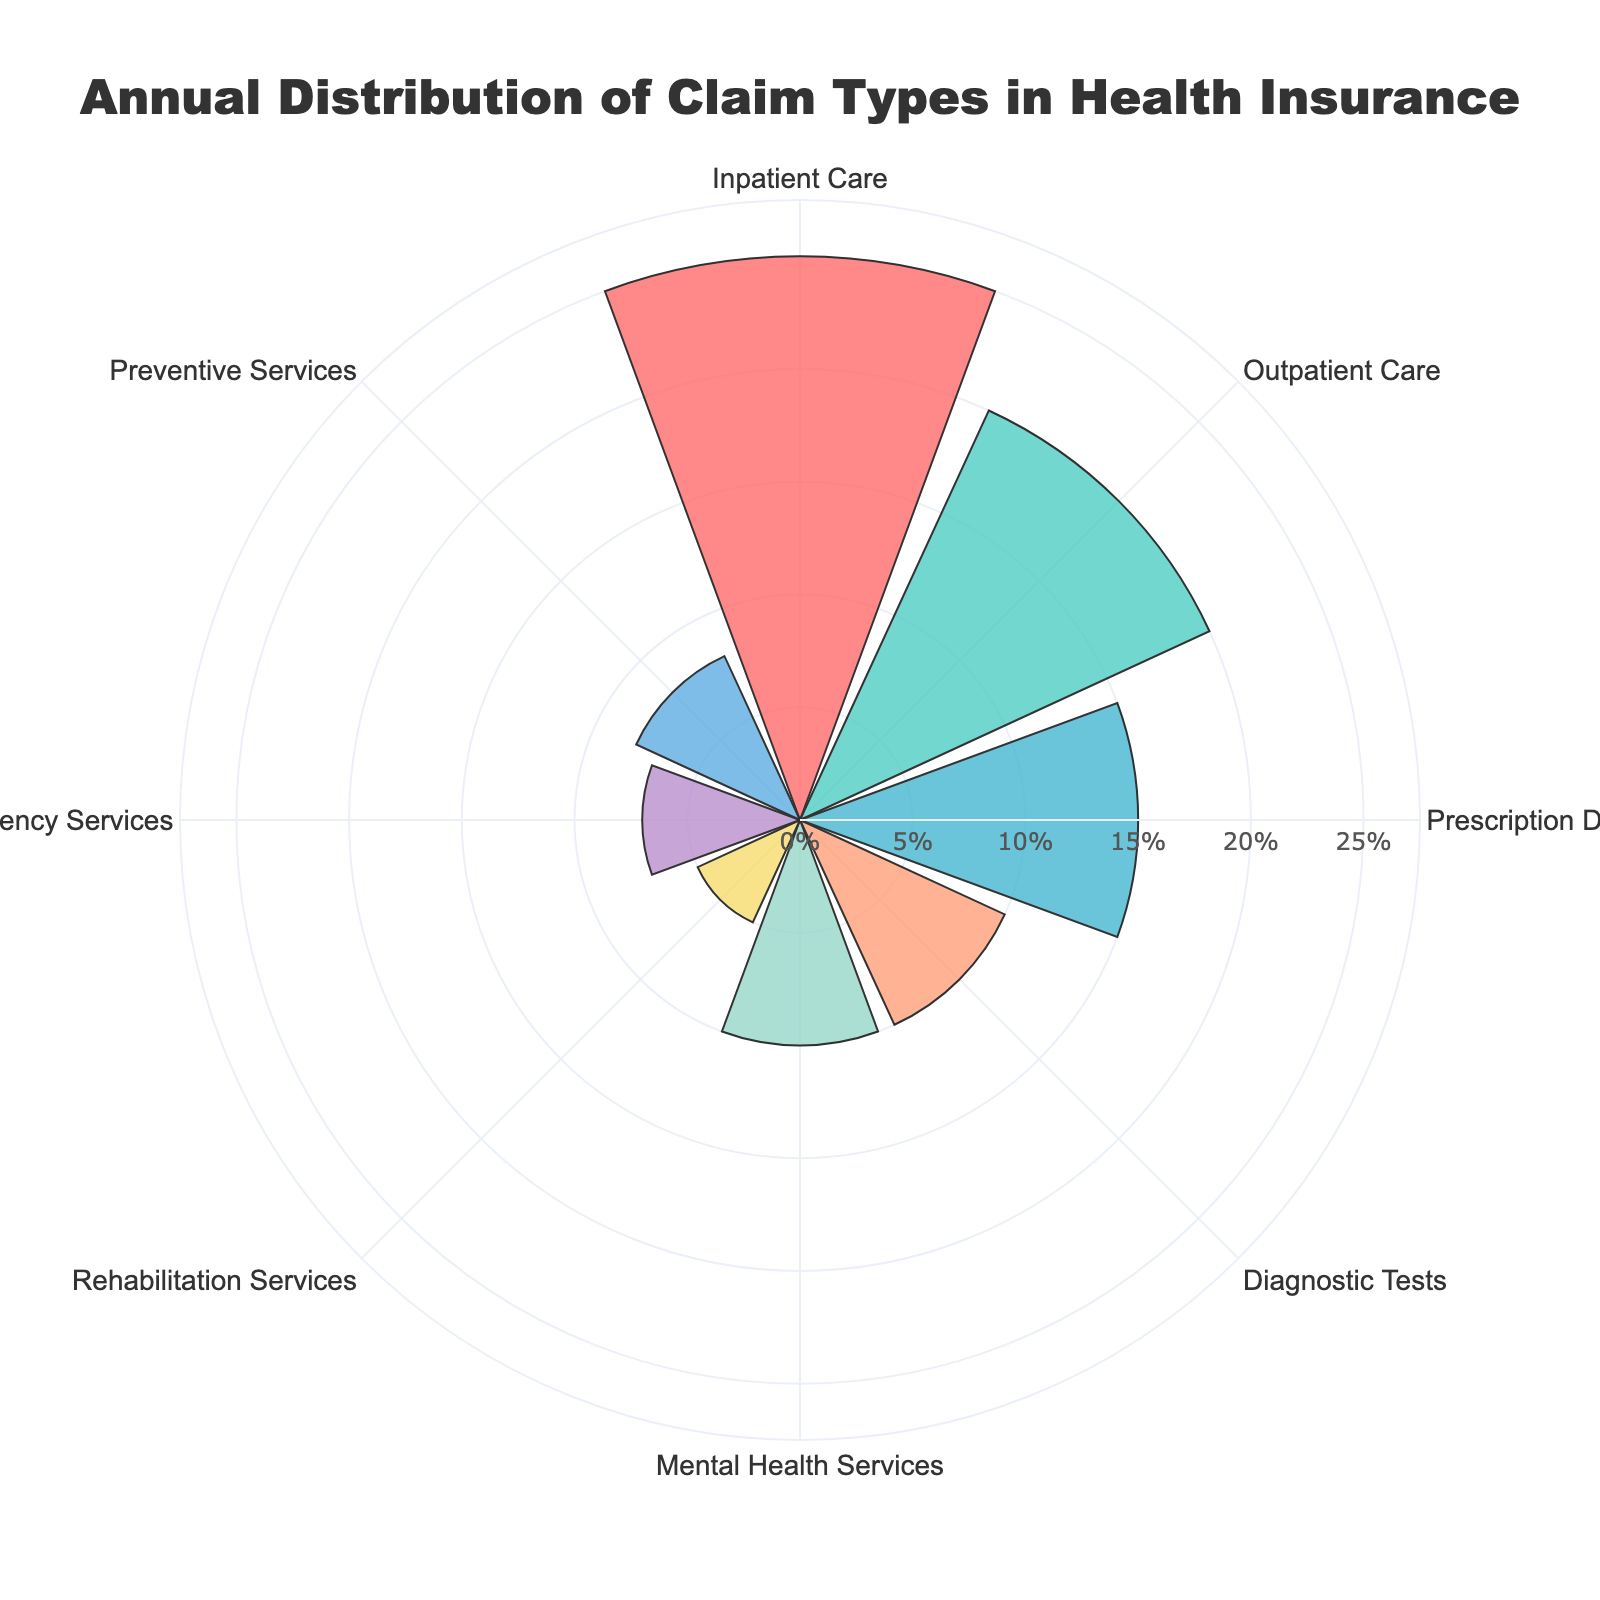What's the title of the figure? The title is usually placed at the top of the plot. In this case, the title reads "Annual Distribution of Claim Types in Health Insurance."
Answer: Annual Distribution of Claim Types in Health Insurance Which claim type has the highest percentage? By observing the length of the bars, the longest bar corresponds to "Inpatient Care," which has a percentage of 25%.
Answer: Inpatient Care How many claim types have a percentage higher than 10%? List out the percentages greater than 10%: Inpatient Care (25%), Outpatient Care (20%), and Prescription Drugs (15%). In total, there are three claim types with percentages higher than 10%.
Answer: 3 What's the combined percentage of Diagnostic Tests and Mental Health Services? Add the percentages of Diagnostic Tests (10%) and Mental Health Services (10%). 10% + 10% = 20%.
Answer: 20% Compare the percentage of Outpatient Care to Emergency Services. Which is higher and by how much? Outpatient Care has a percentage of 20%, while Emergency Services has 7%. The difference is 20% - 7% = 13%. Outpatient Care is higher.
Answer: Outpatient Care by 13% What is the average percentage of all claim types? Sum all the percentages: 25% + 20% + 15% + 10% + 10% + 5% + 7% + 8% = 100%. There are 8 claim types, so the average is 100% / 8 = 12.5%.
Answer: 12.5% Which claim types have the same percentage? By examining the lengths of the bars, both Diagnostic Tests and Mental Health Services have a percentage of 10%.
Answer: Diagnostic Tests and Mental Health Services What's the difference in percentage between the claim type with the highest percentage and the one with the lowest? The highest percentage is for Inpatient Care (25%) and the lowest is Rehabilitation Services (5%). The difference is 25% - 5% = 20%.
Answer: 20% Based on the rose chart, is the percentage of Preventive Services closer to that of Mental Health Services or Emergency Services? Preventive Services has a percentage of 8%, Mental Health Services 10%, and Emergency Services 7%. The difference with Preventive Services is 2% for Mental Health Services and 1% for Emergency Services. Thus, it is closer to Emergency Services.
Answer: Emergency Services 